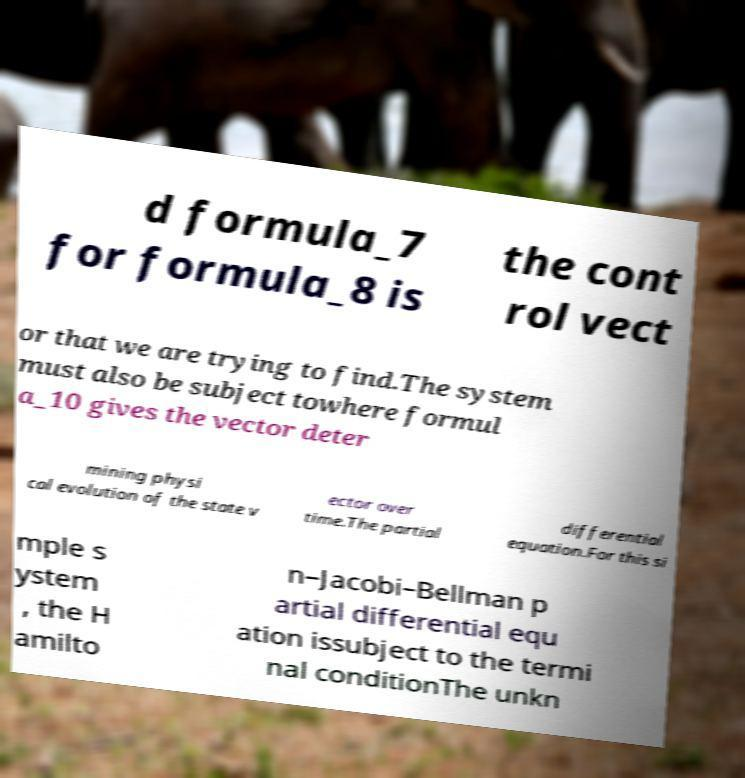Could you assist in decoding the text presented in this image and type it out clearly? d formula_7 for formula_8 is the cont rol vect or that we are trying to find.The system must also be subject towhere formul a_10 gives the vector deter mining physi cal evolution of the state v ector over time.The partial differential equation.For this si mple s ystem , the H amilto n–Jacobi–Bellman p artial differential equ ation issubject to the termi nal conditionThe unkn 